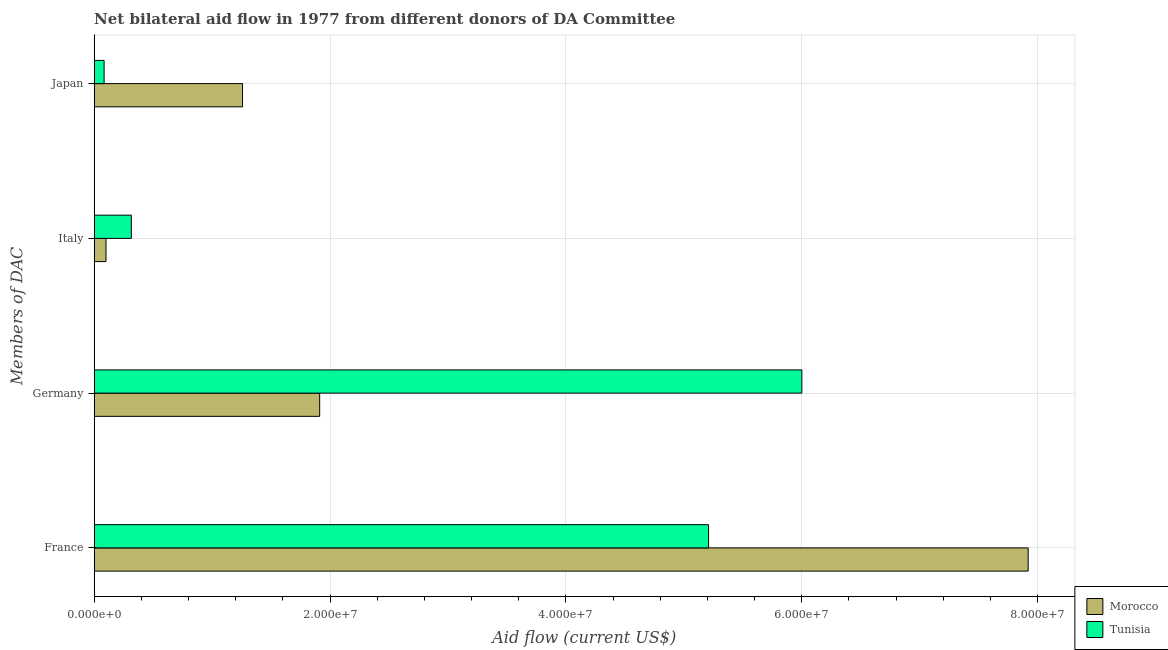How many different coloured bars are there?
Offer a very short reply. 2. How many groups of bars are there?
Provide a succinct answer. 4. How many bars are there on the 4th tick from the bottom?
Your answer should be very brief. 2. What is the label of the 4th group of bars from the top?
Provide a succinct answer. France. What is the amount of aid given by france in Morocco?
Offer a very short reply. 7.92e+07. Across all countries, what is the maximum amount of aid given by italy?
Provide a short and direct response. 3.15e+06. Across all countries, what is the minimum amount of aid given by japan?
Offer a very short reply. 8.40e+05. In which country was the amount of aid given by germany maximum?
Give a very brief answer. Tunisia. In which country was the amount of aid given by italy minimum?
Provide a succinct answer. Morocco. What is the total amount of aid given by france in the graph?
Your response must be concise. 1.31e+08. What is the difference between the amount of aid given by italy in Morocco and that in Tunisia?
Keep it short and to the point. -2.15e+06. What is the difference between the amount of aid given by italy in Morocco and the amount of aid given by japan in Tunisia?
Ensure brevity in your answer.  1.60e+05. What is the average amount of aid given by germany per country?
Provide a succinct answer. 3.96e+07. What is the difference between the amount of aid given by france and amount of aid given by germany in Tunisia?
Provide a succinct answer. -7.91e+06. What is the ratio of the amount of aid given by italy in Tunisia to that in Morocco?
Keep it short and to the point. 3.15. Is the amount of aid given by japan in Tunisia less than that in Morocco?
Offer a very short reply. Yes. Is the difference between the amount of aid given by germany in Tunisia and Morocco greater than the difference between the amount of aid given by france in Tunisia and Morocco?
Your response must be concise. Yes. What is the difference between the highest and the second highest amount of aid given by italy?
Ensure brevity in your answer.  2.15e+06. What is the difference between the highest and the lowest amount of aid given by germany?
Make the answer very short. 4.09e+07. In how many countries, is the amount of aid given by japan greater than the average amount of aid given by japan taken over all countries?
Make the answer very short. 1. Is the sum of the amount of aid given by japan in Morocco and Tunisia greater than the maximum amount of aid given by germany across all countries?
Ensure brevity in your answer.  No. Is it the case that in every country, the sum of the amount of aid given by germany and amount of aid given by france is greater than the sum of amount of aid given by italy and amount of aid given by japan?
Keep it short and to the point. No. What does the 2nd bar from the top in Italy represents?
Your answer should be compact. Morocco. What does the 2nd bar from the bottom in France represents?
Offer a very short reply. Tunisia. How many legend labels are there?
Give a very brief answer. 2. What is the title of the graph?
Make the answer very short. Net bilateral aid flow in 1977 from different donors of DA Committee. What is the label or title of the X-axis?
Make the answer very short. Aid flow (current US$). What is the label or title of the Y-axis?
Make the answer very short. Members of DAC. What is the Aid flow (current US$) of Morocco in France?
Your answer should be very brief. 7.92e+07. What is the Aid flow (current US$) of Tunisia in France?
Make the answer very short. 5.21e+07. What is the Aid flow (current US$) of Morocco in Germany?
Offer a very short reply. 1.91e+07. What is the Aid flow (current US$) of Tunisia in Germany?
Make the answer very short. 6.00e+07. What is the Aid flow (current US$) of Morocco in Italy?
Your response must be concise. 1.00e+06. What is the Aid flow (current US$) of Tunisia in Italy?
Make the answer very short. 3.15e+06. What is the Aid flow (current US$) in Morocco in Japan?
Ensure brevity in your answer.  1.26e+07. What is the Aid flow (current US$) in Tunisia in Japan?
Offer a very short reply. 8.40e+05. Across all Members of DAC, what is the maximum Aid flow (current US$) in Morocco?
Offer a terse response. 7.92e+07. Across all Members of DAC, what is the maximum Aid flow (current US$) in Tunisia?
Offer a terse response. 6.00e+07. Across all Members of DAC, what is the minimum Aid flow (current US$) of Morocco?
Give a very brief answer. 1.00e+06. Across all Members of DAC, what is the minimum Aid flow (current US$) in Tunisia?
Ensure brevity in your answer.  8.40e+05. What is the total Aid flow (current US$) of Morocco in the graph?
Keep it short and to the point. 1.12e+08. What is the total Aid flow (current US$) in Tunisia in the graph?
Keep it short and to the point. 1.16e+08. What is the difference between the Aid flow (current US$) of Morocco in France and that in Germany?
Offer a terse response. 6.01e+07. What is the difference between the Aid flow (current US$) in Tunisia in France and that in Germany?
Your answer should be compact. -7.91e+06. What is the difference between the Aid flow (current US$) in Morocco in France and that in Italy?
Provide a succinct answer. 7.82e+07. What is the difference between the Aid flow (current US$) in Tunisia in France and that in Italy?
Ensure brevity in your answer.  4.90e+07. What is the difference between the Aid flow (current US$) in Morocco in France and that in Japan?
Provide a short and direct response. 6.66e+07. What is the difference between the Aid flow (current US$) of Tunisia in France and that in Japan?
Provide a short and direct response. 5.13e+07. What is the difference between the Aid flow (current US$) in Morocco in Germany and that in Italy?
Your answer should be compact. 1.81e+07. What is the difference between the Aid flow (current US$) of Tunisia in Germany and that in Italy?
Make the answer very short. 5.69e+07. What is the difference between the Aid flow (current US$) of Morocco in Germany and that in Japan?
Your answer should be very brief. 6.54e+06. What is the difference between the Aid flow (current US$) of Tunisia in Germany and that in Japan?
Provide a short and direct response. 5.92e+07. What is the difference between the Aid flow (current US$) in Morocco in Italy and that in Japan?
Provide a succinct answer. -1.16e+07. What is the difference between the Aid flow (current US$) of Tunisia in Italy and that in Japan?
Offer a terse response. 2.31e+06. What is the difference between the Aid flow (current US$) in Morocco in France and the Aid flow (current US$) in Tunisia in Germany?
Your answer should be very brief. 1.92e+07. What is the difference between the Aid flow (current US$) in Morocco in France and the Aid flow (current US$) in Tunisia in Italy?
Ensure brevity in your answer.  7.60e+07. What is the difference between the Aid flow (current US$) of Morocco in France and the Aid flow (current US$) of Tunisia in Japan?
Your response must be concise. 7.84e+07. What is the difference between the Aid flow (current US$) of Morocco in Germany and the Aid flow (current US$) of Tunisia in Italy?
Provide a short and direct response. 1.60e+07. What is the difference between the Aid flow (current US$) of Morocco in Germany and the Aid flow (current US$) of Tunisia in Japan?
Ensure brevity in your answer.  1.83e+07. What is the difference between the Aid flow (current US$) of Morocco in Italy and the Aid flow (current US$) of Tunisia in Japan?
Provide a short and direct response. 1.60e+05. What is the average Aid flow (current US$) of Morocco per Members of DAC?
Your answer should be very brief. 2.80e+07. What is the average Aid flow (current US$) of Tunisia per Members of DAC?
Provide a short and direct response. 2.90e+07. What is the difference between the Aid flow (current US$) in Morocco and Aid flow (current US$) in Tunisia in France?
Provide a short and direct response. 2.71e+07. What is the difference between the Aid flow (current US$) of Morocco and Aid flow (current US$) of Tunisia in Germany?
Make the answer very short. -4.09e+07. What is the difference between the Aid flow (current US$) of Morocco and Aid flow (current US$) of Tunisia in Italy?
Provide a succinct answer. -2.15e+06. What is the difference between the Aid flow (current US$) of Morocco and Aid flow (current US$) of Tunisia in Japan?
Ensure brevity in your answer.  1.17e+07. What is the ratio of the Aid flow (current US$) of Morocco in France to that in Germany?
Your answer should be compact. 4.14. What is the ratio of the Aid flow (current US$) in Tunisia in France to that in Germany?
Offer a terse response. 0.87. What is the ratio of the Aid flow (current US$) of Morocco in France to that in Italy?
Make the answer very short. 79.2. What is the ratio of the Aid flow (current US$) of Tunisia in France to that in Italy?
Your answer should be very brief. 16.54. What is the ratio of the Aid flow (current US$) of Morocco in France to that in Japan?
Your answer should be very brief. 6.3. What is the ratio of the Aid flow (current US$) of Tunisia in France to that in Japan?
Your response must be concise. 62.02. What is the ratio of the Aid flow (current US$) of Morocco in Germany to that in Italy?
Your answer should be very brief. 19.12. What is the ratio of the Aid flow (current US$) of Tunisia in Germany to that in Italy?
Keep it short and to the point. 19.05. What is the ratio of the Aid flow (current US$) in Morocco in Germany to that in Japan?
Keep it short and to the point. 1.52. What is the ratio of the Aid flow (current US$) of Tunisia in Germany to that in Japan?
Provide a short and direct response. 71.44. What is the ratio of the Aid flow (current US$) of Morocco in Italy to that in Japan?
Offer a terse response. 0.08. What is the ratio of the Aid flow (current US$) in Tunisia in Italy to that in Japan?
Make the answer very short. 3.75. What is the difference between the highest and the second highest Aid flow (current US$) of Morocco?
Your answer should be very brief. 6.01e+07. What is the difference between the highest and the second highest Aid flow (current US$) in Tunisia?
Make the answer very short. 7.91e+06. What is the difference between the highest and the lowest Aid flow (current US$) of Morocco?
Offer a terse response. 7.82e+07. What is the difference between the highest and the lowest Aid flow (current US$) of Tunisia?
Provide a short and direct response. 5.92e+07. 